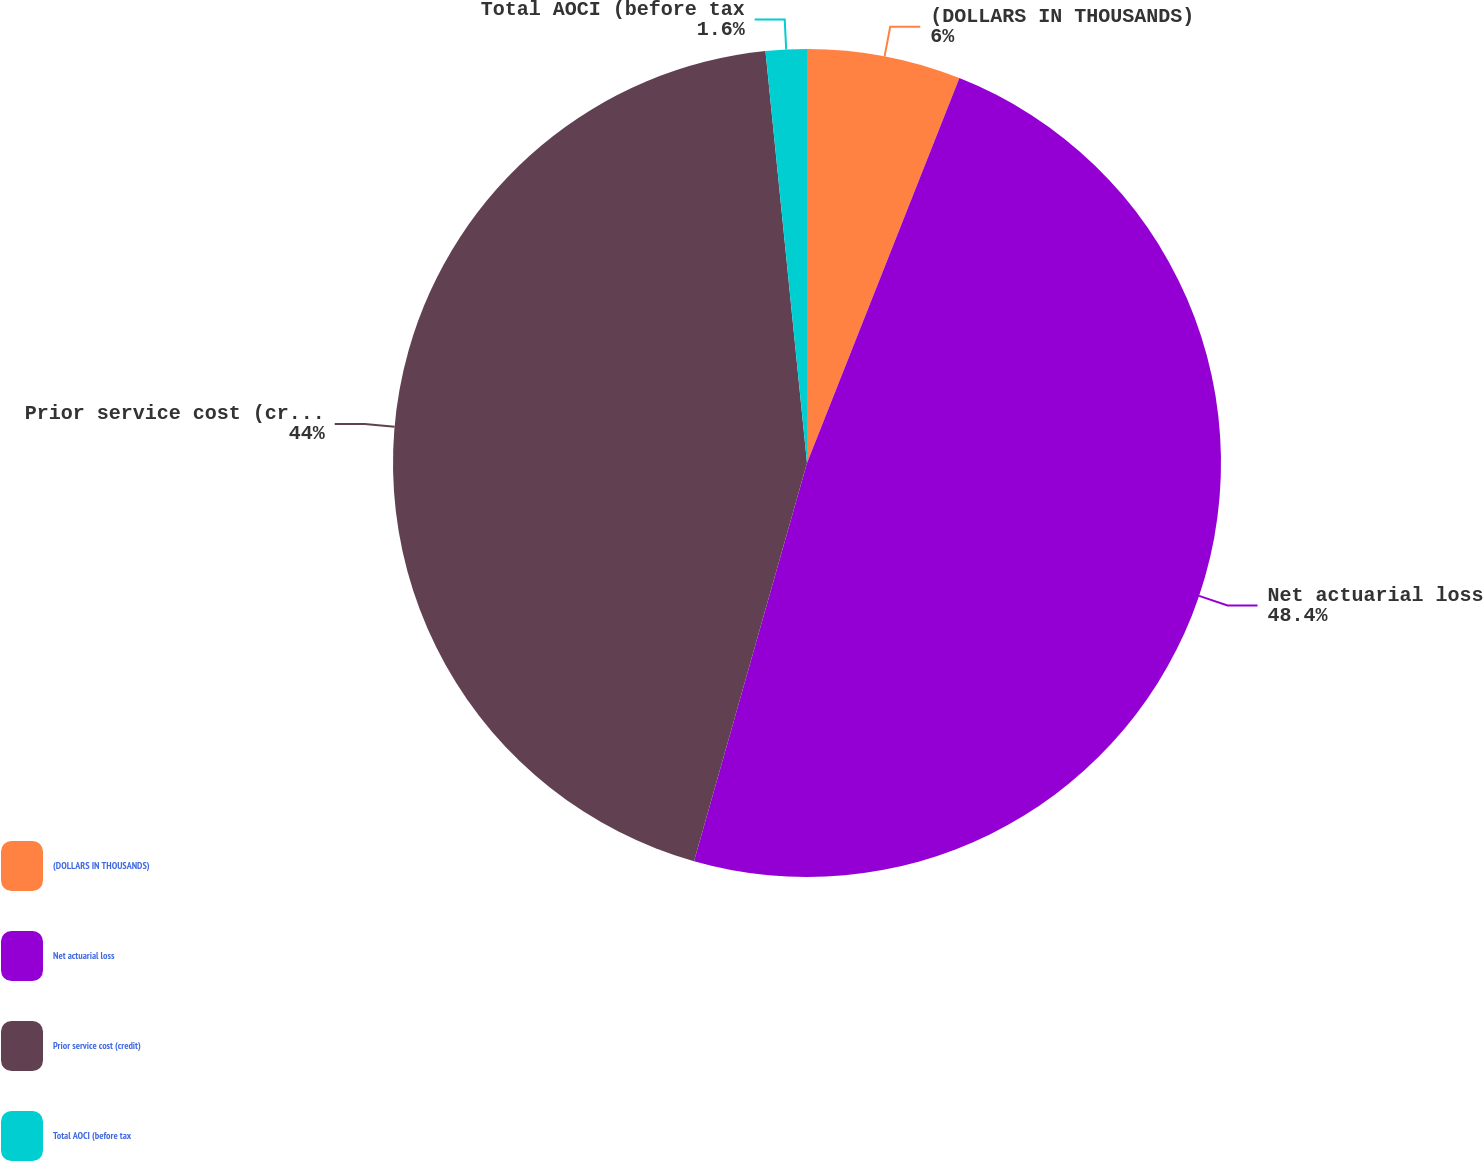Convert chart to OTSL. <chart><loc_0><loc_0><loc_500><loc_500><pie_chart><fcel>(DOLLARS IN THOUSANDS)<fcel>Net actuarial loss<fcel>Prior service cost (credit)<fcel>Total AOCI (before tax<nl><fcel>6.0%<fcel>48.4%<fcel>44.0%<fcel>1.6%<nl></chart> 